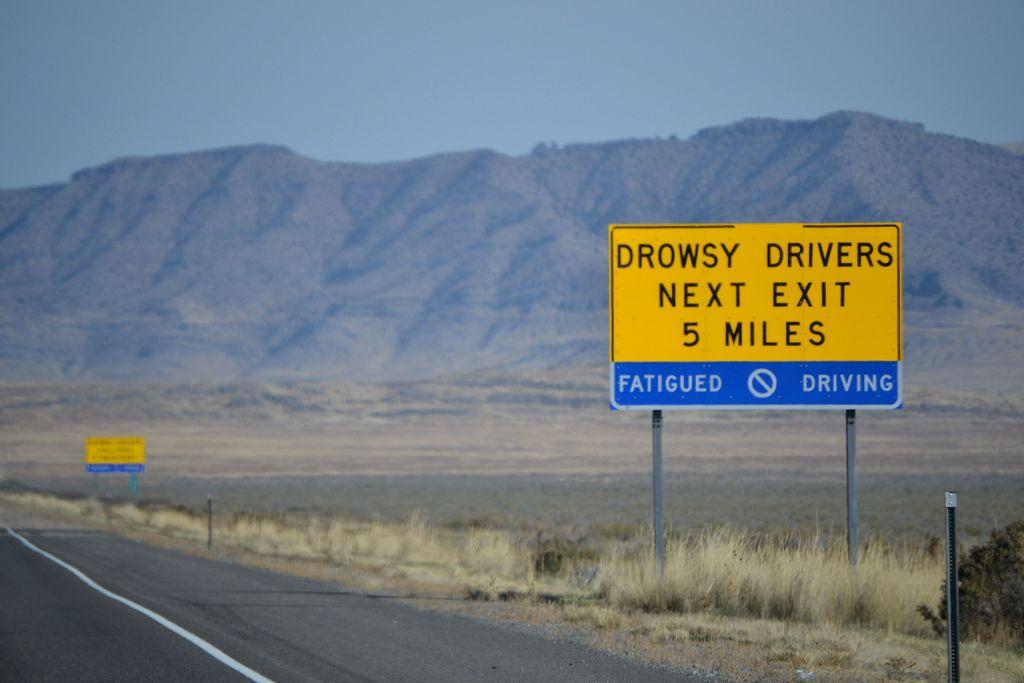How far away does the sign say?
Make the answer very short. 5 miles. What type of drivers are at the next exit?
Your answer should be very brief. Drowsy. 